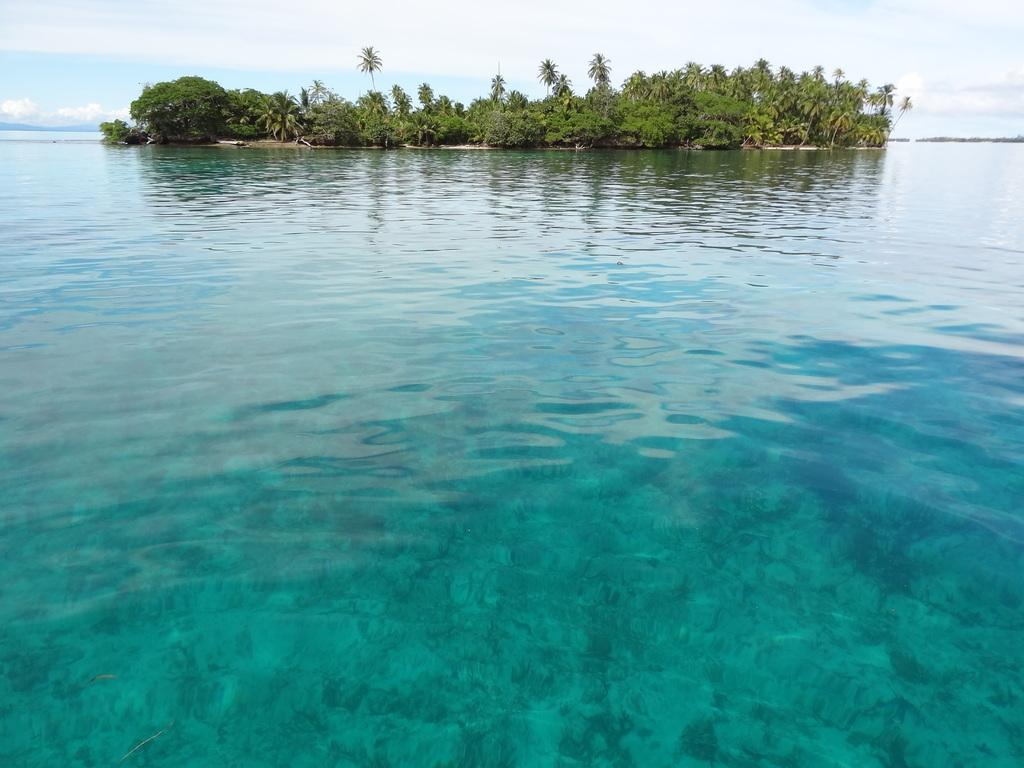What color is the water in the image? The water in the image is blue. What can be found on the island in the image? There are trees on the island in the image. What is visible in the background of the image? The sky is visible in the background of the image. What type of law does the lawyer specialize in, as seen in the image? There is no lawyer present in the image. What scientific experiment is being conducted on the island in the image? There is no scientific experiment being conducted in the image; it features blue water, trees on an island, and a visible sky. 